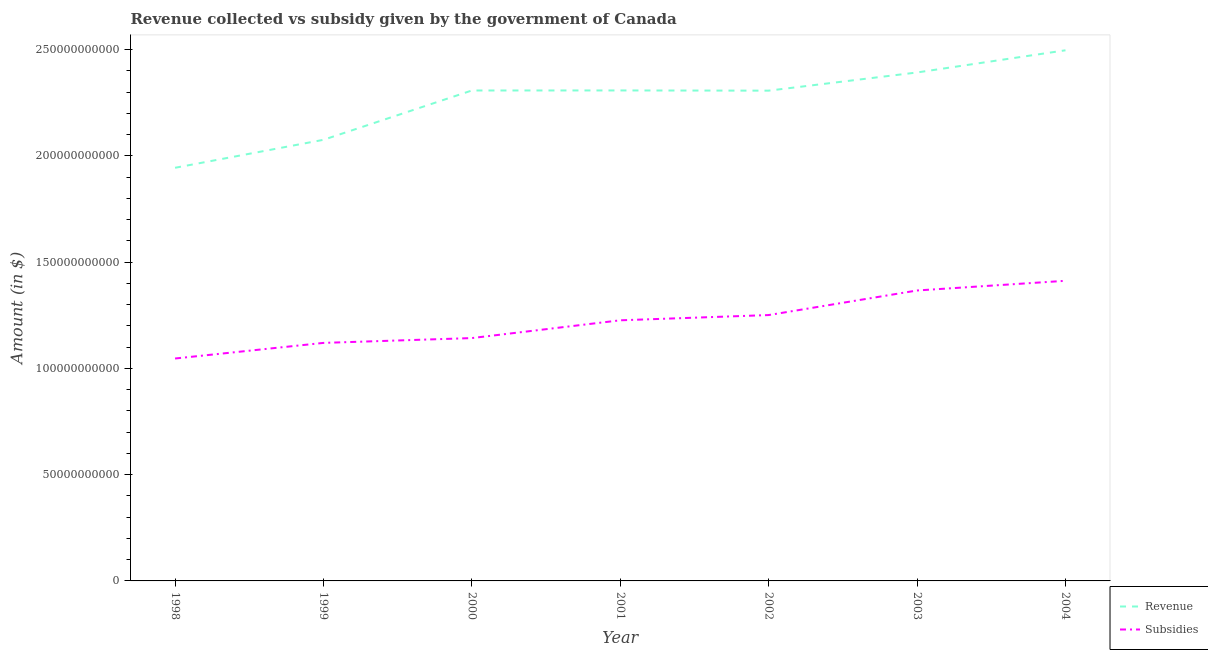What is the amount of subsidies given in 2002?
Provide a short and direct response. 1.25e+11. Across all years, what is the maximum amount of subsidies given?
Your response must be concise. 1.41e+11. Across all years, what is the minimum amount of subsidies given?
Provide a succinct answer. 1.05e+11. In which year was the amount of subsidies given maximum?
Your answer should be compact. 2004. In which year was the amount of subsidies given minimum?
Your answer should be very brief. 1998. What is the total amount of subsidies given in the graph?
Ensure brevity in your answer.  8.57e+11. What is the difference between the amount of revenue collected in 1998 and that in 2004?
Give a very brief answer. -5.53e+1. What is the difference between the amount of revenue collected in 2003 and the amount of subsidies given in 2002?
Offer a terse response. 1.14e+11. What is the average amount of subsidies given per year?
Offer a terse response. 1.22e+11. In the year 2002, what is the difference between the amount of subsidies given and amount of revenue collected?
Keep it short and to the point. -1.06e+11. What is the ratio of the amount of revenue collected in 1998 to that in 2001?
Provide a succinct answer. 0.84. Is the difference between the amount of subsidies given in 1999 and 2001 greater than the difference between the amount of revenue collected in 1999 and 2001?
Provide a short and direct response. Yes. What is the difference between the highest and the second highest amount of subsidies given?
Keep it short and to the point. 4.56e+09. What is the difference between the highest and the lowest amount of subsidies given?
Give a very brief answer. 3.66e+1. Is the sum of the amount of subsidies given in 1999 and 2001 greater than the maximum amount of revenue collected across all years?
Provide a succinct answer. No. Is the amount of subsidies given strictly greater than the amount of revenue collected over the years?
Provide a short and direct response. No. How many years are there in the graph?
Give a very brief answer. 7. Are the values on the major ticks of Y-axis written in scientific E-notation?
Provide a short and direct response. No. Does the graph contain any zero values?
Give a very brief answer. No. Where does the legend appear in the graph?
Your answer should be very brief. Bottom right. What is the title of the graph?
Your answer should be compact. Revenue collected vs subsidy given by the government of Canada. Does "Subsidies" appear as one of the legend labels in the graph?
Your response must be concise. Yes. What is the label or title of the Y-axis?
Keep it short and to the point. Amount (in $). What is the Amount (in $) in Revenue in 1998?
Keep it short and to the point. 1.94e+11. What is the Amount (in $) of Subsidies in 1998?
Your answer should be very brief. 1.05e+11. What is the Amount (in $) in Revenue in 1999?
Give a very brief answer. 2.08e+11. What is the Amount (in $) of Subsidies in 1999?
Offer a very short reply. 1.12e+11. What is the Amount (in $) in Revenue in 2000?
Provide a short and direct response. 2.31e+11. What is the Amount (in $) in Subsidies in 2000?
Offer a very short reply. 1.14e+11. What is the Amount (in $) of Revenue in 2001?
Your response must be concise. 2.31e+11. What is the Amount (in $) in Subsidies in 2001?
Make the answer very short. 1.23e+11. What is the Amount (in $) of Revenue in 2002?
Your answer should be very brief. 2.31e+11. What is the Amount (in $) in Subsidies in 2002?
Offer a very short reply. 1.25e+11. What is the Amount (in $) in Revenue in 2003?
Your answer should be compact. 2.39e+11. What is the Amount (in $) in Subsidies in 2003?
Provide a short and direct response. 1.37e+11. What is the Amount (in $) of Revenue in 2004?
Offer a terse response. 2.50e+11. What is the Amount (in $) in Subsidies in 2004?
Make the answer very short. 1.41e+11. Across all years, what is the maximum Amount (in $) in Revenue?
Your answer should be very brief. 2.50e+11. Across all years, what is the maximum Amount (in $) in Subsidies?
Provide a succinct answer. 1.41e+11. Across all years, what is the minimum Amount (in $) in Revenue?
Ensure brevity in your answer.  1.94e+11. Across all years, what is the minimum Amount (in $) in Subsidies?
Provide a short and direct response. 1.05e+11. What is the total Amount (in $) in Revenue in the graph?
Your answer should be very brief. 1.58e+12. What is the total Amount (in $) of Subsidies in the graph?
Keep it short and to the point. 8.57e+11. What is the difference between the Amount (in $) in Revenue in 1998 and that in 1999?
Your answer should be very brief. -1.32e+1. What is the difference between the Amount (in $) of Subsidies in 1998 and that in 1999?
Ensure brevity in your answer.  -7.34e+09. What is the difference between the Amount (in $) in Revenue in 1998 and that in 2000?
Provide a short and direct response. -3.64e+1. What is the difference between the Amount (in $) in Subsidies in 1998 and that in 2000?
Give a very brief answer. -9.61e+09. What is the difference between the Amount (in $) of Revenue in 1998 and that in 2001?
Provide a short and direct response. -3.64e+1. What is the difference between the Amount (in $) of Subsidies in 1998 and that in 2001?
Your answer should be very brief. -1.80e+1. What is the difference between the Amount (in $) of Revenue in 1998 and that in 2002?
Keep it short and to the point. -3.63e+1. What is the difference between the Amount (in $) of Subsidies in 1998 and that in 2002?
Ensure brevity in your answer.  -2.04e+1. What is the difference between the Amount (in $) of Revenue in 1998 and that in 2003?
Your answer should be compact. -4.49e+1. What is the difference between the Amount (in $) of Subsidies in 1998 and that in 2003?
Give a very brief answer. -3.20e+1. What is the difference between the Amount (in $) of Revenue in 1998 and that in 2004?
Offer a very short reply. -5.53e+1. What is the difference between the Amount (in $) of Subsidies in 1998 and that in 2004?
Provide a short and direct response. -3.66e+1. What is the difference between the Amount (in $) of Revenue in 1999 and that in 2000?
Ensure brevity in your answer.  -2.32e+1. What is the difference between the Amount (in $) in Subsidies in 1999 and that in 2000?
Keep it short and to the point. -2.27e+09. What is the difference between the Amount (in $) of Revenue in 1999 and that in 2001?
Offer a terse response. -2.32e+1. What is the difference between the Amount (in $) of Subsidies in 1999 and that in 2001?
Your answer should be compact. -1.06e+1. What is the difference between the Amount (in $) in Revenue in 1999 and that in 2002?
Your response must be concise. -2.31e+1. What is the difference between the Amount (in $) in Subsidies in 1999 and that in 2002?
Your answer should be very brief. -1.31e+1. What is the difference between the Amount (in $) in Revenue in 1999 and that in 2003?
Offer a very short reply. -3.17e+1. What is the difference between the Amount (in $) in Subsidies in 1999 and that in 2003?
Offer a terse response. -2.47e+1. What is the difference between the Amount (in $) in Revenue in 1999 and that in 2004?
Make the answer very short. -4.21e+1. What is the difference between the Amount (in $) in Subsidies in 1999 and that in 2004?
Make the answer very short. -2.92e+1. What is the difference between the Amount (in $) of Revenue in 2000 and that in 2001?
Your answer should be very brief. -2.20e+07. What is the difference between the Amount (in $) of Subsidies in 2000 and that in 2001?
Provide a succinct answer. -8.36e+09. What is the difference between the Amount (in $) in Revenue in 2000 and that in 2002?
Keep it short and to the point. 7.50e+07. What is the difference between the Amount (in $) of Subsidies in 2000 and that in 2002?
Make the answer very short. -1.08e+1. What is the difference between the Amount (in $) of Revenue in 2000 and that in 2003?
Keep it short and to the point. -8.48e+09. What is the difference between the Amount (in $) in Subsidies in 2000 and that in 2003?
Make the answer very short. -2.24e+1. What is the difference between the Amount (in $) of Revenue in 2000 and that in 2004?
Offer a terse response. -1.89e+1. What is the difference between the Amount (in $) of Subsidies in 2000 and that in 2004?
Your response must be concise. -2.70e+1. What is the difference between the Amount (in $) in Revenue in 2001 and that in 2002?
Offer a terse response. 9.70e+07. What is the difference between the Amount (in $) of Subsidies in 2001 and that in 2002?
Keep it short and to the point. -2.47e+09. What is the difference between the Amount (in $) in Revenue in 2001 and that in 2003?
Your answer should be very brief. -8.46e+09. What is the difference between the Amount (in $) in Subsidies in 2001 and that in 2003?
Your response must be concise. -1.40e+1. What is the difference between the Amount (in $) of Revenue in 2001 and that in 2004?
Offer a terse response. -1.89e+1. What is the difference between the Amount (in $) in Subsidies in 2001 and that in 2004?
Your answer should be compact. -1.86e+1. What is the difference between the Amount (in $) of Revenue in 2002 and that in 2003?
Ensure brevity in your answer.  -8.56e+09. What is the difference between the Amount (in $) of Subsidies in 2002 and that in 2003?
Offer a terse response. -1.16e+1. What is the difference between the Amount (in $) of Revenue in 2002 and that in 2004?
Provide a short and direct response. -1.90e+1. What is the difference between the Amount (in $) in Subsidies in 2002 and that in 2004?
Give a very brief answer. -1.61e+1. What is the difference between the Amount (in $) in Revenue in 2003 and that in 2004?
Keep it short and to the point. -1.04e+1. What is the difference between the Amount (in $) of Subsidies in 2003 and that in 2004?
Give a very brief answer. -4.56e+09. What is the difference between the Amount (in $) of Revenue in 1998 and the Amount (in $) of Subsidies in 1999?
Give a very brief answer. 8.24e+1. What is the difference between the Amount (in $) of Revenue in 1998 and the Amount (in $) of Subsidies in 2000?
Your answer should be compact. 8.01e+1. What is the difference between the Amount (in $) of Revenue in 1998 and the Amount (in $) of Subsidies in 2001?
Provide a succinct answer. 7.18e+1. What is the difference between the Amount (in $) of Revenue in 1998 and the Amount (in $) of Subsidies in 2002?
Give a very brief answer. 6.93e+1. What is the difference between the Amount (in $) of Revenue in 1998 and the Amount (in $) of Subsidies in 2003?
Give a very brief answer. 5.77e+1. What is the difference between the Amount (in $) of Revenue in 1998 and the Amount (in $) of Subsidies in 2004?
Your response must be concise. 5.32e+1. What is the difference between the Amount (in $) of Revenue in 1999 and the Amount (in $) of Subsidies in 2000?
Your response must be concise. 9.33e+1. What is the difference between the Amount (in $) of Revenue in 1999 and the Amount (in $) of Subsidies in 2001?
Make the answer very short. 8.49e+1. What is the difference between the Amount (in $) of Revenue in 1999 and the Amount (in $) of Subsidies in 2002?
Your answer should be compact. 8.25e+1. What is the difference between the Amount (in $) in Revenue in 1999 and the Amount (in $) in Subsidies in 2003?
Provide a succinct answer. 7.09e+1. What is the difference between the Amount (in $) of Revenue in 1999 and the Amount (in $) of Subsidies in 2004?
Your answer should be very brief. 6.63e+1. What is the difference between the Amount (in $) in Revenue in 2000 and the Amount (in $) in Subsidies in 2001?
Your answer should be very brief. 1.08e+11. What is the difference between the Amount (in $) of Revenue in 2000 and the Amount (in $) of Subsidies in 2002?
Offer a very short reply. 1.06e+11. What is the difference between the Amount (in $) in Revenue in 2000 and the Amount (in $) in Subsidies in 2003?
Offer a terse response. 9.41e+1. What is the difference between the Amount (in $) of Revenue in 2000 and the Amount (in $) of Subsidies in 2004?
Provide a succinct answer. 8.95e+1. What is the difference between the Amount (in $) of Revenue in 2001 and the Amount (in $) of Subsidies in 2002?
Your answer should be compact. 1.06e+11. What is the difference between the Amount (in $) in Revenue in 2001 and the Amount (in $) in Subsidies in 2003?
Provide a succinct answer. 9.41e+1. What is the difference between the Amount (in $) in Revenue in 2001 and the Amount (in $) in Subsidies in 2004?
Give a very brief answer. 8.96e+1. What is the difference between the Amount (in $) of Revenue in 2002 and the Amount (in $) of Subsidies in 2003?
Your answer should be very brief. 9.40e+1. What is the difference between the Amount (in $) in Revenue in 2002 and the Amount (in $) in Subsidies in 2004?
Give a very brief answer. 8.95e+1. What is the difference between the Amount (in $) of Revenue in 2003 and the Amount (in $) of Subsidies in 2004?
Your answer should be very brief. 9.80e+1. What is the average Amount (in $) in Revenue per year?
Provide a short and direct response. 2.26e+11. What is the average Amount (in $) in Subsidies per year?
Your response must be concise. 1.22e+11. In the year 1998, what is the difference between the Amount (in $) in Revenue and Amount (in $) in Subsidies?
Offer a terse response. 8.97e+1. In the year 1999, what is the difference between the Amount (in $) in Revenue and Amount (in $) in Subsidies?
Provide a short and direct response. 9.56e+1. In the year 2000, what is the difference between the Amount (in $) in Revenue and Amount (in $) in Subsidies?
Give a very brief answer. 1.16e+11. In the year 2001, what is the difference between the Amount (in $) of Revenue and Amount (in $) of Subsidies?
Your answer should be very brief. 1.08e+11. In the year 2002, what is the difference between the Amount (in $) in Revenue and Amount (in $) in Subsidies?
Ensure brevity in your answer.  1.06e+11. In the year 2003, what is the difference between the Amount (in $) in Revenue and Amount (in $) in Subsidies?
Make the answer very short. 1.03e+11. In the year 2004, what is the difference between the Amount (in $) in Revenue and Amount (in $) in Subsidies?
Offer a very short reply. 1.08e+11. What is the ratio of the Amount (in $) of Revenue in 1998 to that in 1999?
Your response must be concise. 0.94. What is the ratio of the Amount (in $) of Subsidies in 1998 to that in 1999?
Offer a very short reply. 0.93. What is the ratio of the Amount (in $) in Revenue in 1998 to that in 2000?
Your answer should be very brief. 0.84. What is the ratio of the Amount (in $) in Subsidies in 1998 to that in 2000?
Provide a succinct answer. 0.92. What is the ratio of the Amount (in $) of Revenue in 1998 to that in 2001?
Make the answer very short. 0.84. What is the ratio of the Amount (in $) of Subsidies in 1998 to that in 2001?
Give a very brief answer. 0.85. What is the ratio of the Amount (in $) of Revenue in 1998 to that in 2002?
Your answer should be very brief. 0.84. What is the ratio of the Amount (in $) of Subsidies in 1998 to that in 2002?
Provide a succinct answer. 0.84. What is the ratio of the Amount (in $) in Revenue in 1998 to that in 2003?
Offer a terse response. 0.81. What is the ratio of the Amount (in $) in Subsidies in 1998 to that in 2003?
Your answer should be very brief. 0.77. What is the ratio of the Amount (in $) in Revenue in 1998 to that in 2004?
Provide a short and direct response. 0.78. What is the ratio of the Amount (in $) in Subsidies in 1998 to that in 2004?
Your answer should be compact. 0.74. What is the ratio of the Amount (in $) of Revenue in 1999 to that in 2000?
Offer a very short reply. 0.9. What is the ratio of the Amount (in $) in Subsidies in 1999 to that in 2000?
Give a very brief answer. 0.98. What is the ratio of the Amount (in $) in Revenue in 1999 to that in 2001?
Provide a short and direct response. 0.9. What is the ratio of the Amount (in $) of Subsidies in 1999 to that in 2001?
Provide a succinct answer. 0.91. What is the ratio of the Amount (in $) in Revenue in 1999 to that in 2002?
Give a very brief answer. 0.9. What is the ratio of the Amount (in $) of Subsidies in 1999 to that in 2002?
Ensure brevity in your answer.  0.9. What is the ratio of the Amount (in $) of Revenue in 1999 to that in 2003?
Offer a very short reply. 0.87. What is the ratio of the Amount (in $) of Subsidies in 1999 to that in 2003?
Provide a succinct answer. 0.82. What is the ratio of the Amount (in $) in Revenue in 1999 to that in 2004?
Your answer should be very brief. 0.83. What is the ratio of the Amount (in $) of Subsidies in 1999 to that in 2004?
Your answer should be very brief. 0.79. What is the ratio of the Amount (in $) in Subsidies in 2000 to that in 2001?
Offer a terse response. 0.93. What is the ratio of the Amount (in $) in Revenue in 2000 to that in 2002?
Provide a succinct answer. 1. What is the ratio of the Amount (in $) in Subsidies in 2000 to that in 2002?
Offer a terse response. 0.91. What is the ratio of the Amount (in $) in Revenue in 2000 to that in 2003?
Offer a very short reply. 0.96. What is the ratio of the Amount (in $) in Subsidies in 2000 to that in 2003?
Ensure brevity in your answer.  0.84. What is the ratio of the Amount (in $) of Revenue in 2000 to that in 2004?
Offer a very short reply. 0.92. What is the ratio of the Amount (in $) of Subsidies in 2000 to that in 2004?
Your response must be concise. 0.81. What is the ratio of the Amount (in $) in Revenue in 2001 to that in 2002?
Keep it short and to the point. 1. What is the ratio of the Amount (in $) of Subsidies in 2001 to that in 2002?
Your answer should be compact. 0.98. What is the ratio of the Amount (in $) in Revenue in 2001 to that in 2003?
Make the answer very short. 0.96. What is the ratio of the Amount (in $) in Subsidies in 2001 to that in 2003?
Your response must be concise. 0.9. What is the ratio of the Amount (in $) in Revenue in 2001 to that in 2004?
Your answer should be very brief. 0.92. What is the ratio of the Amount (in $) of Subsidies in 2001 to that in 2004?
Give a very brief answer. 0.87. What is the ratio of the Amount (in $) of Revenue in 2002 to that in 2003?
Offer a terse response. 0.96. What is the ratio of the Amount (in $) in Subsidies in 2002 to that in 2003?
Provide a succinct answer. 0.92. What is the ratio of the Amount (in $) of Revenue in 2002 to that in 2004?
Your answer should be compact. 0.92. What is the ratio of the Amount (in $) of Subsidies in 2002 to that in 2004?
Make the answer very short. 0.89. What is the ratio of the Amount (in $) in Revenue in 2003 to that in 2004?
Give a very brief answer. 0.96. What is the ratio of the Amount (in $) of Subsidies in 2003 to that in 2004?
Offer a terse response. 0.97. What is the difference between the highest and the second highest Amount (in $) in Revenue?
Provide a succinct answer. 1.04e+1. What is the difference between the highest and the second highest Amount (in $) of Subsidies?
Your answer should be very brief. 4.56e+09. What is the difference between the highest and the lowest Amount (in $) in Revenue?
Your answer should be compact. 5.53e+1. What is the difference between the highest and the lowest Amount (in $) of Subsidies?
Keep it short and to the point. 3.66e+1. 